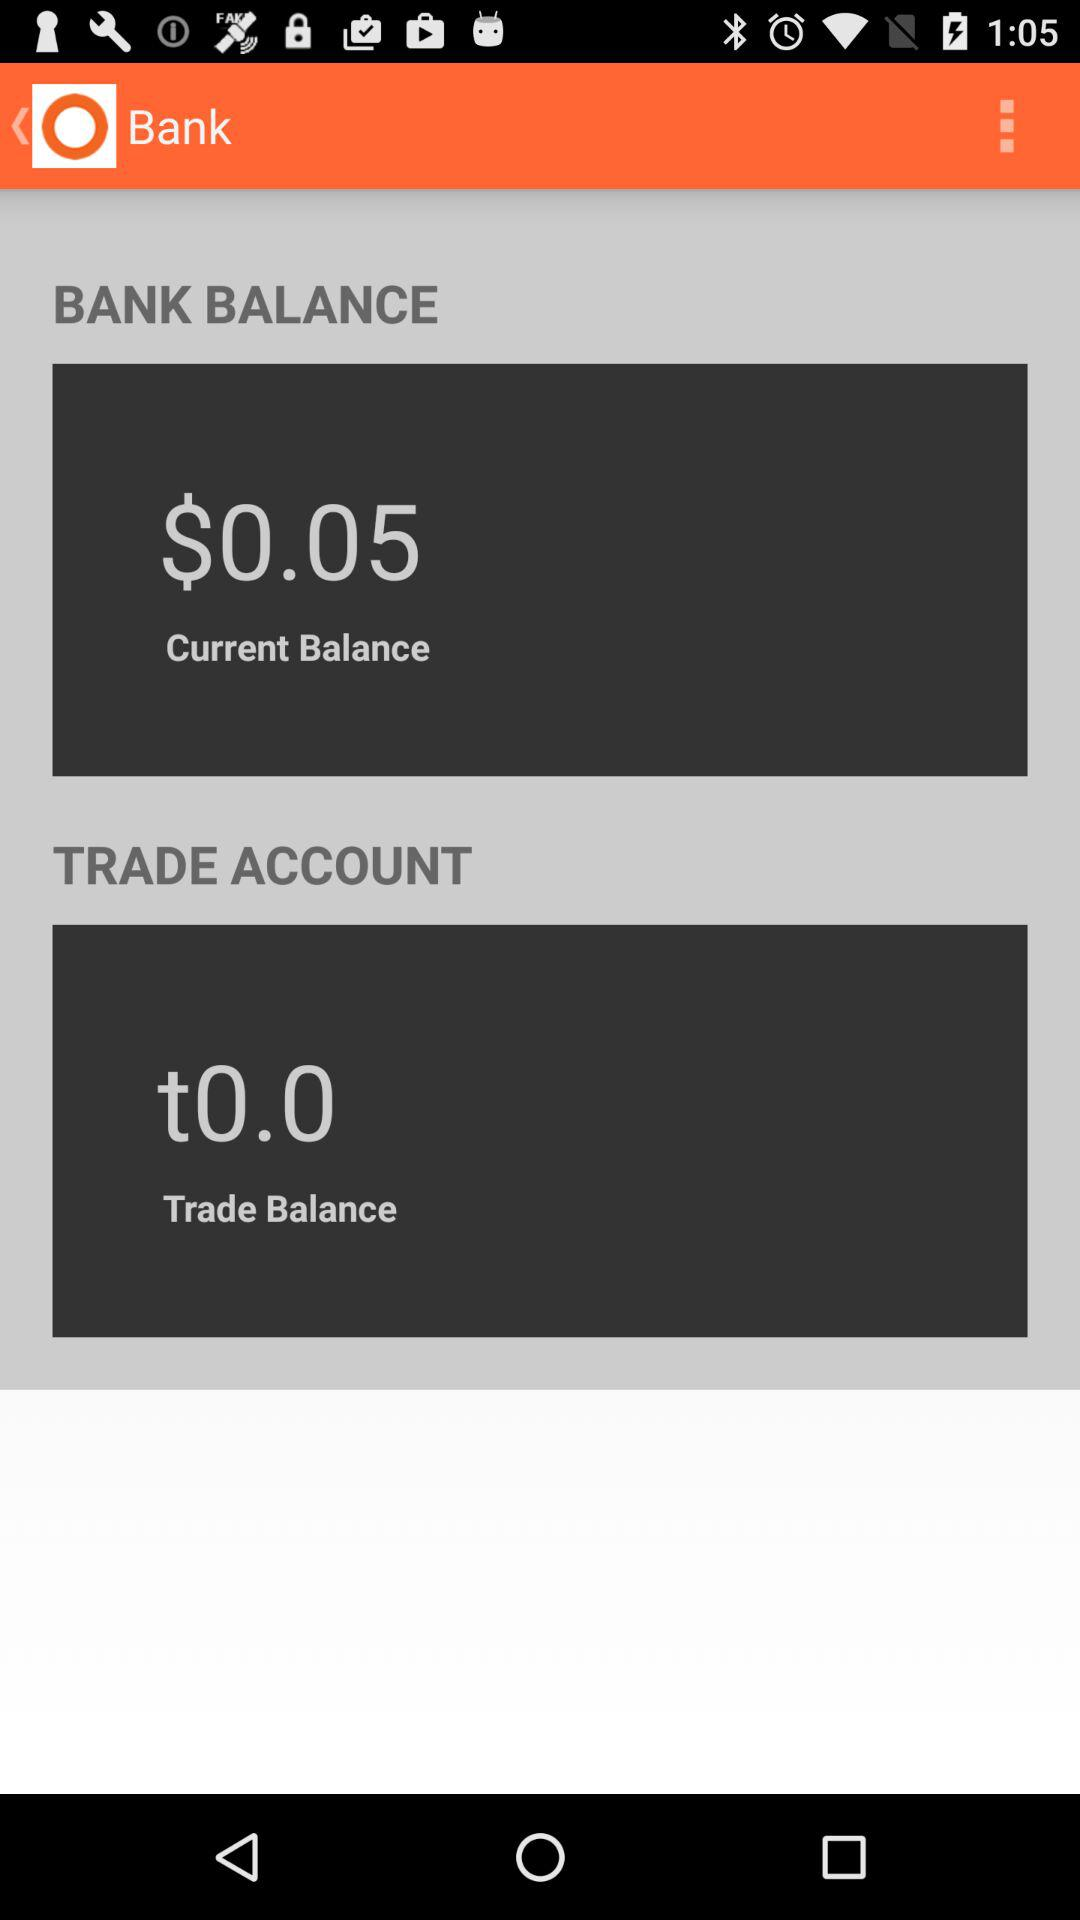How much is more in the bank balance than the trade balance?
Answer the question using a single word or phrase. $0.05 